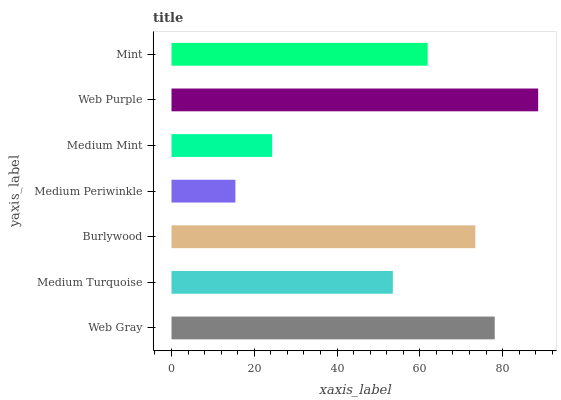Is Medium Periwinkle the minimum?
Answer yes or no. Yes. Is Web Purple the maximum?
Answer yes or no. Yes. Is Medium Turquoise the minimum?
Answer yes or no. No. Is Medium Turquoise the maximum?
Answer yes or no. No. Is Web Gray greater than Medium Turquoise?
Answer yes or no. Yes. Is Medium Turquoise less than Web Gray?
Answer yes or no. Yes. Is Medium Turquoise greater than Web Gray?
Answer yes or no. No. Is Web Gray less than Medium Turquoise?
Answer yes or no. No. Is Mint the high median?
Answer yes or no. Yes. Is Mint the low median?
Answer yes or no. Yes. Is Medium Turquoise the high median?
Answer yes or no. No. Is Medium Mint the low median?
Answer yes or no. No. 